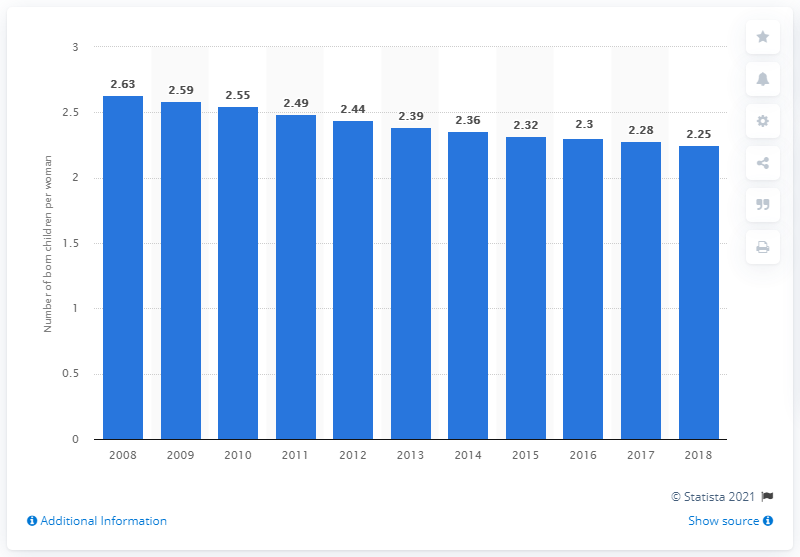Indicate a few pertinent items in this graphic. In 2018, Peru's fertility rate was 2.25. 